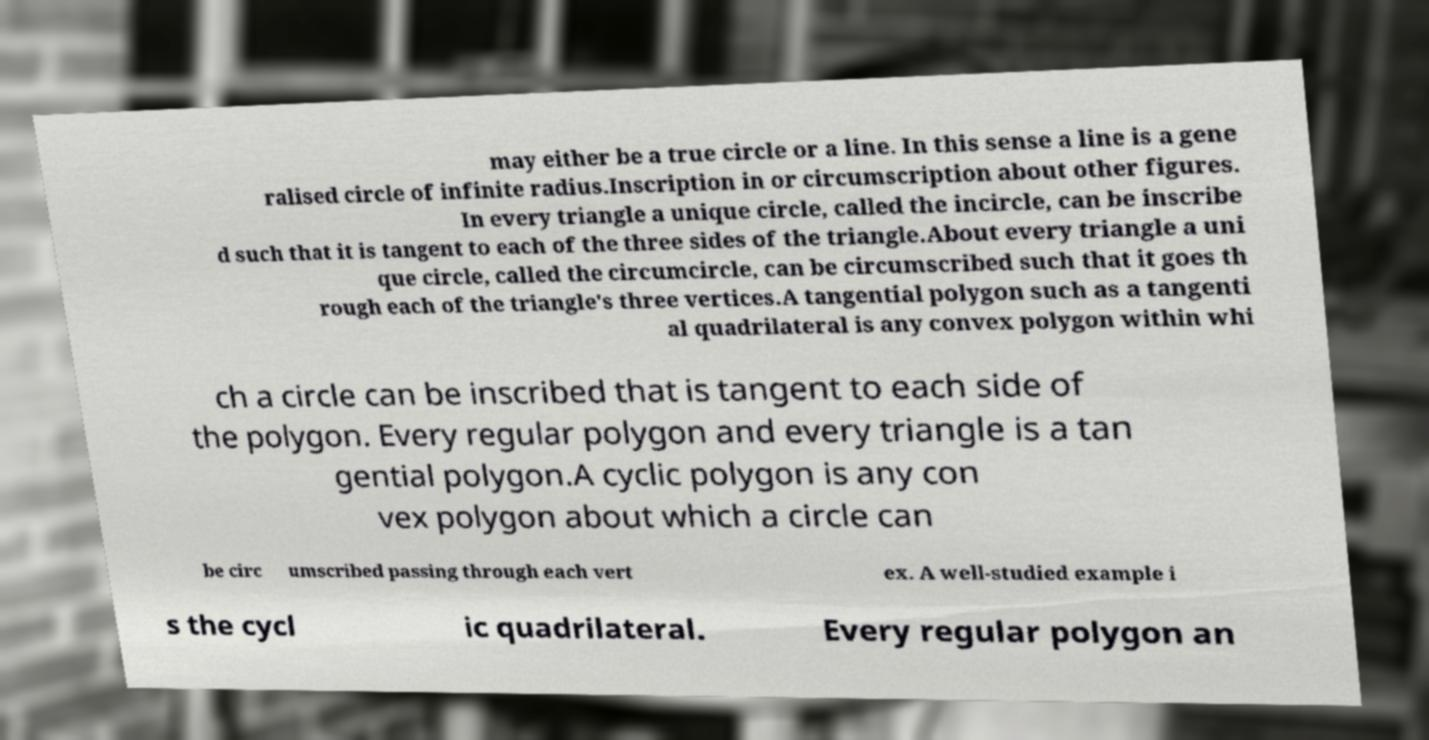Please identify and transcribe the text found in this image. may either be a true circle or a line. In this sense a line is a gene ralised circle of infinite radius.Inscription in or circumscription about other figures. In every triangle a unique circle, called the incircle, can be inscribe d such that it is tangent to each of the three sides of the triangle.About every triangle a uni que circle, called the circumcircle, can be circumscribed such that it goes th rough each of the triangle's three vertices.A tangential polygon such as a tangenti al quadrilateral is any convex polygon within whi ch a circle can be inscribed that is tangent to each side of the polygon. Every regular polygon and every triangle is a tan gential polygon.A cyclic polygon is any con vex polygon about which a circle can be circ umscribed passing through each vert ex. A well-studied example i s the cycl ic quadrilateral. Every regular polygon an 